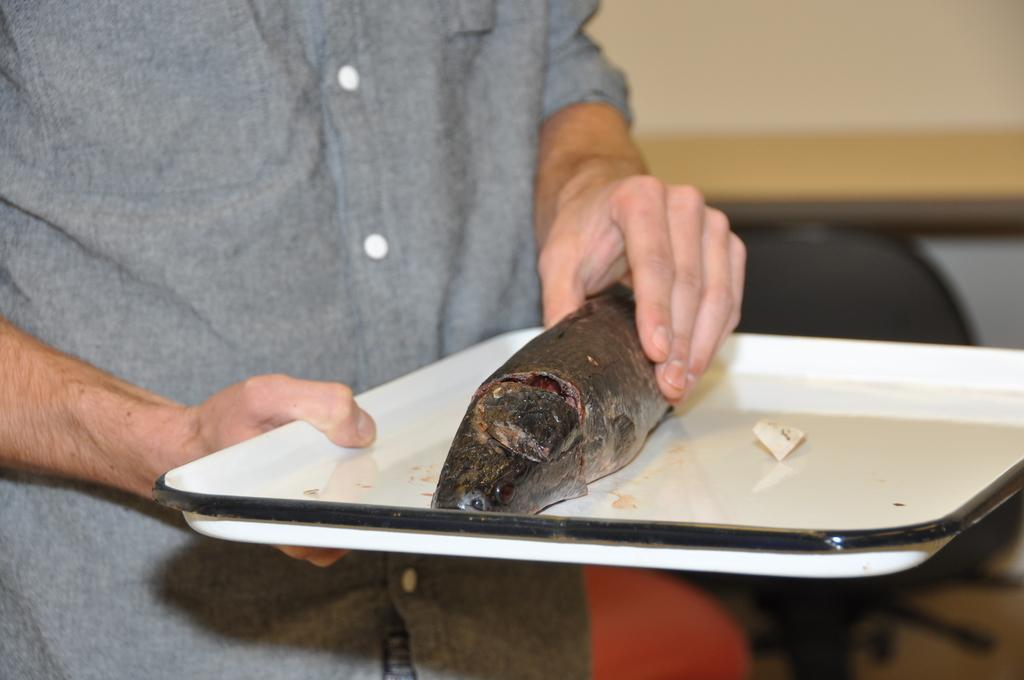Who or what is the main subject in the image? There is a person in the image. What is the person holding in the image? The person is holding a white tray. What is on the tray that the person is holding? The tray contains fish. Can you describe the background of the image? The background of the image is blurred. How does the wind affect the person holding the tray in the image? There is no wind present in the image, so it cannot affect the person holding the tray. 